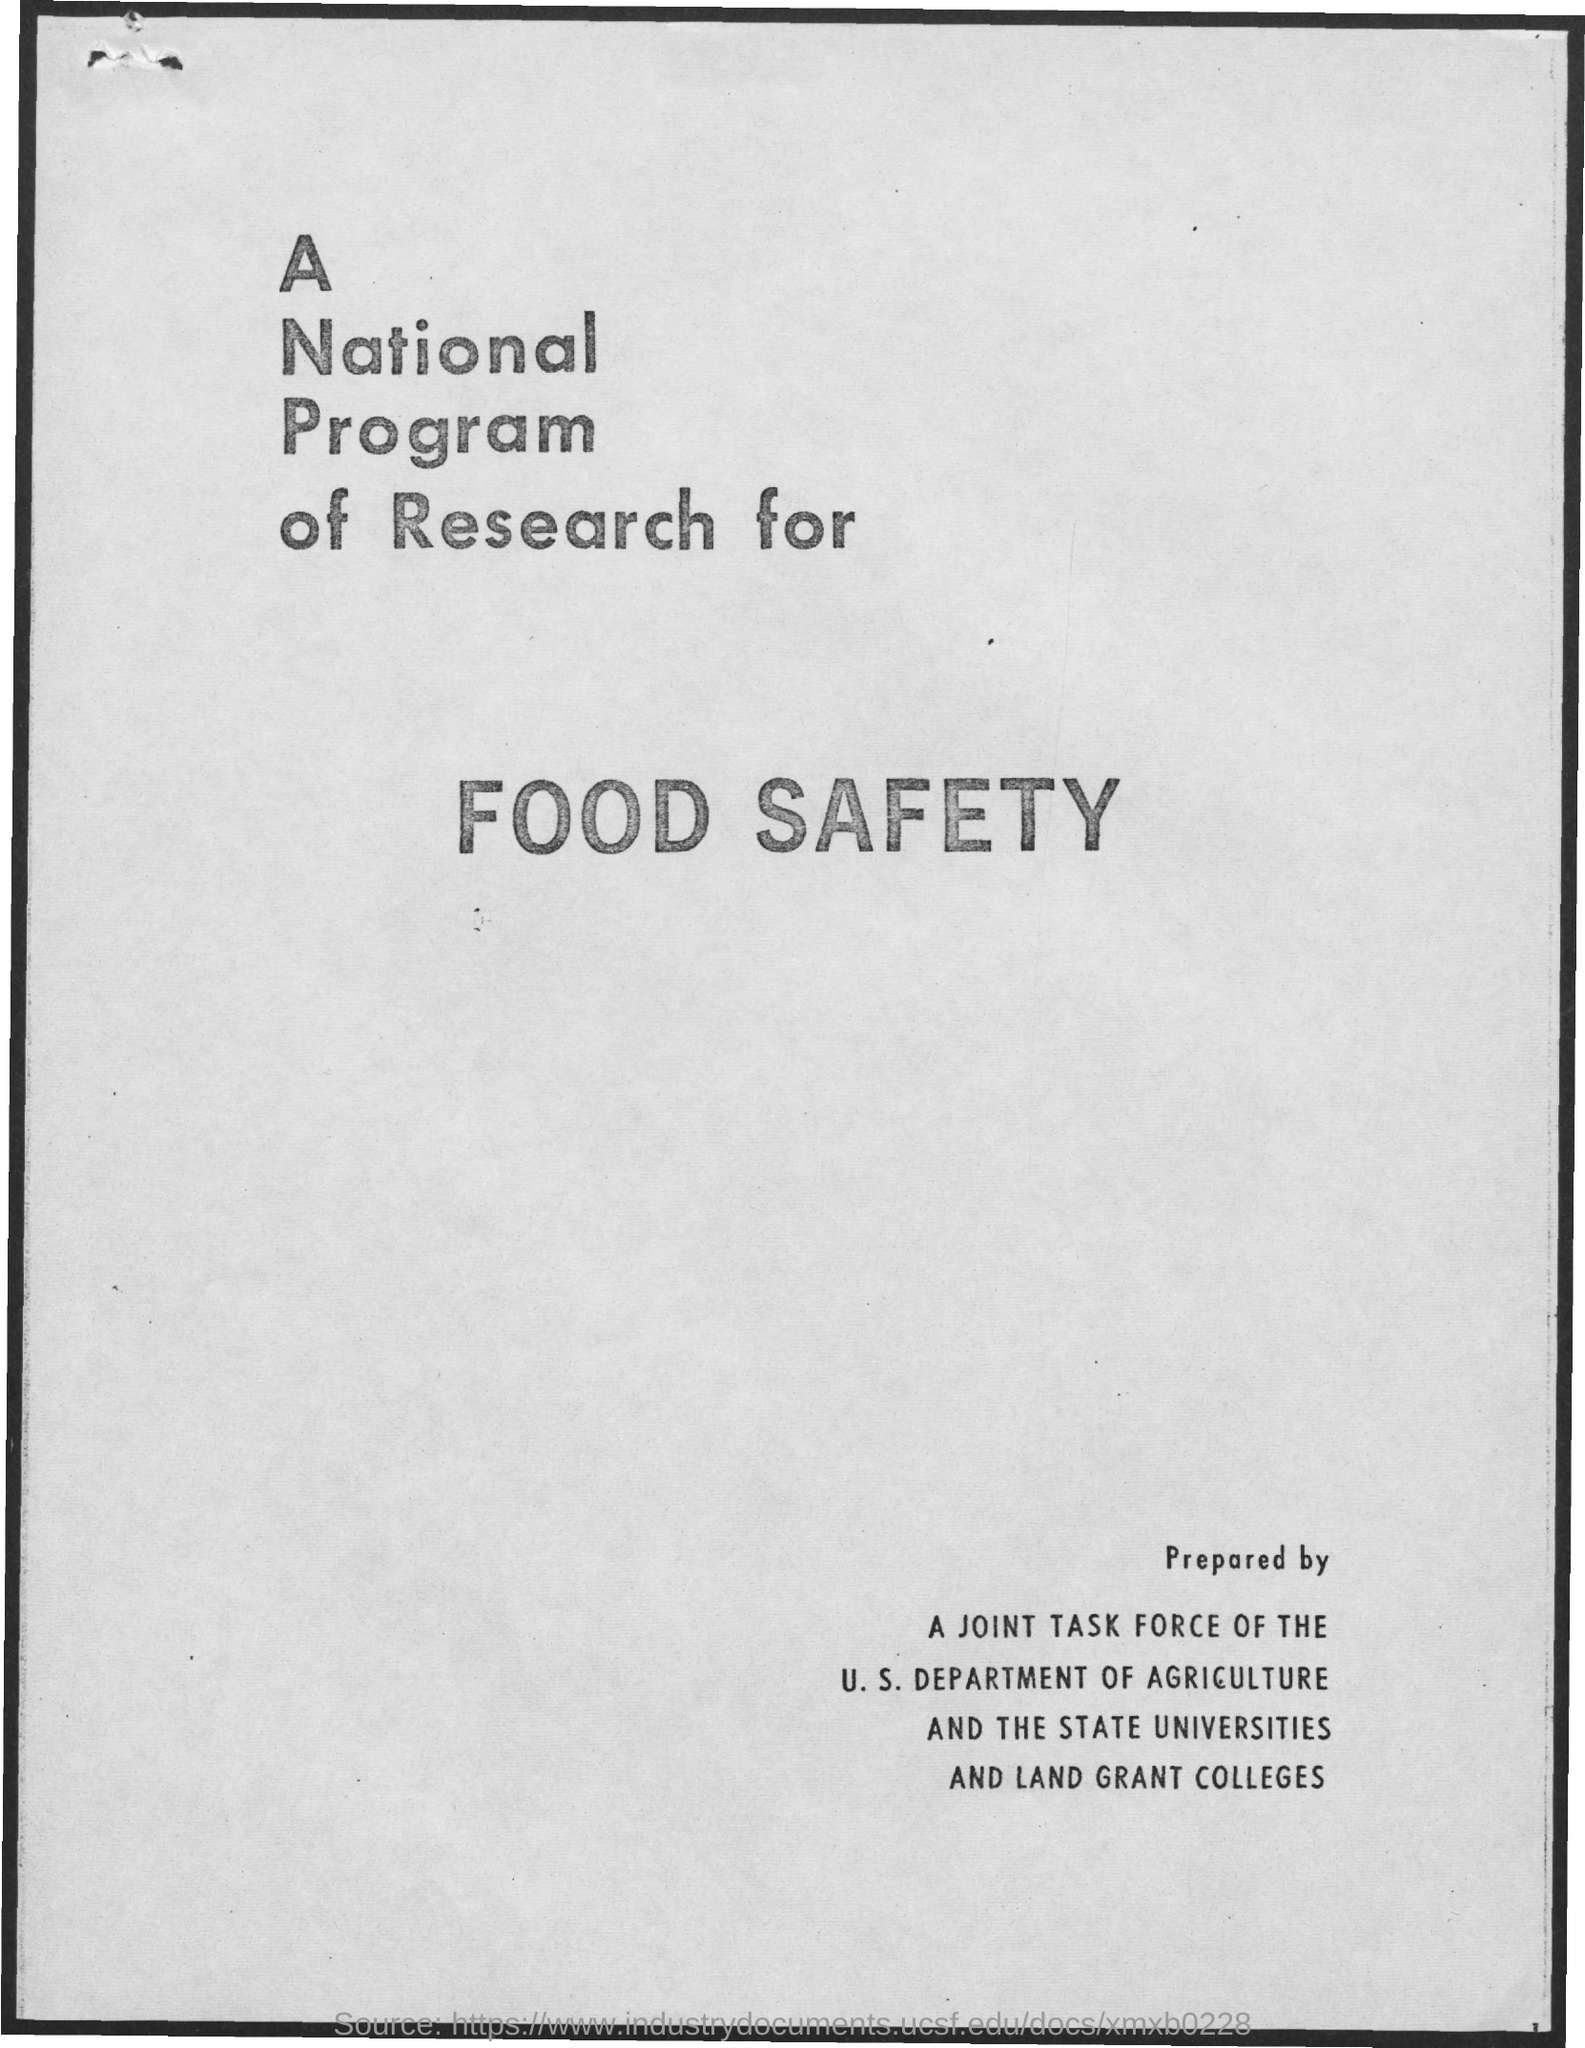Highlight a few significant elements in this photo. The first title in the document is 'A national program of research for...' 